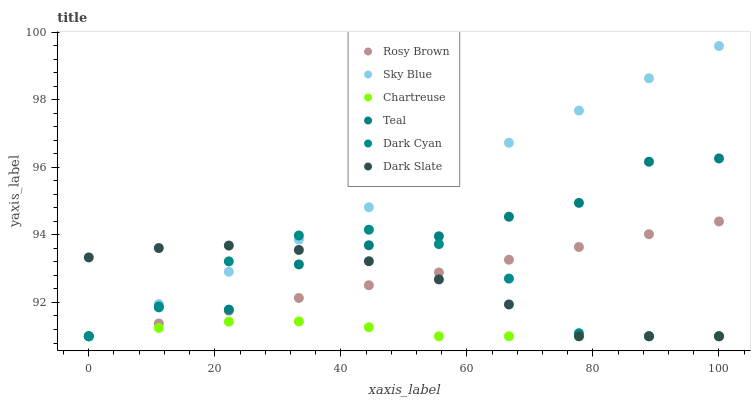Does Chartreuse have the minimum area under the curve?
Answer yes or no. Yes. Does Sky Blue have the maximum area under the curve?
Answer yes or no. Yes. Does Dark Slate have the minimum area under the curve?
Answer yes or no. No. Does Dark Slate have the maximum area under the curve?
Answer yes or no. No. Is Sky Blue the smoothest?
Answer yes or no. Yes. Is Teal the roughest?
Answer yes or no. Yes. Is Dark Slate the smoothest?
Answer yes or no. No. Is Dark Slate the roughest?
Answer yes or no. No. Does Rosy Brown have the lowest value?
Answer yes or no. Yes. Does Sky Blue have the highest value?
Answer yes or no. Yes. Does Dark Slate have the highest value?
Answer yes or no. No. Does Chartreuse intersect Teal?
Answer yes or no. Yes. Is Chartreuse less than Teal?
Answer yes or no. No. Is Chartreuse greater than Teal?
Answer yes or no. No. 